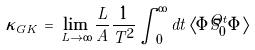Convert formula to latex. <formula><loc_0><loc_0><loc_500><loc_500>\kappa _ { G K } \, = \, \lim _ { L \to \infty } \frac { L } { A } \frac { 1 } { T ^ { 2 } } \int _ { 0 } ^ { \infty } d t \, \langle \Phi { \hat { S } } _ { 0 } ^ { t } \Phi \rangle</formula> 